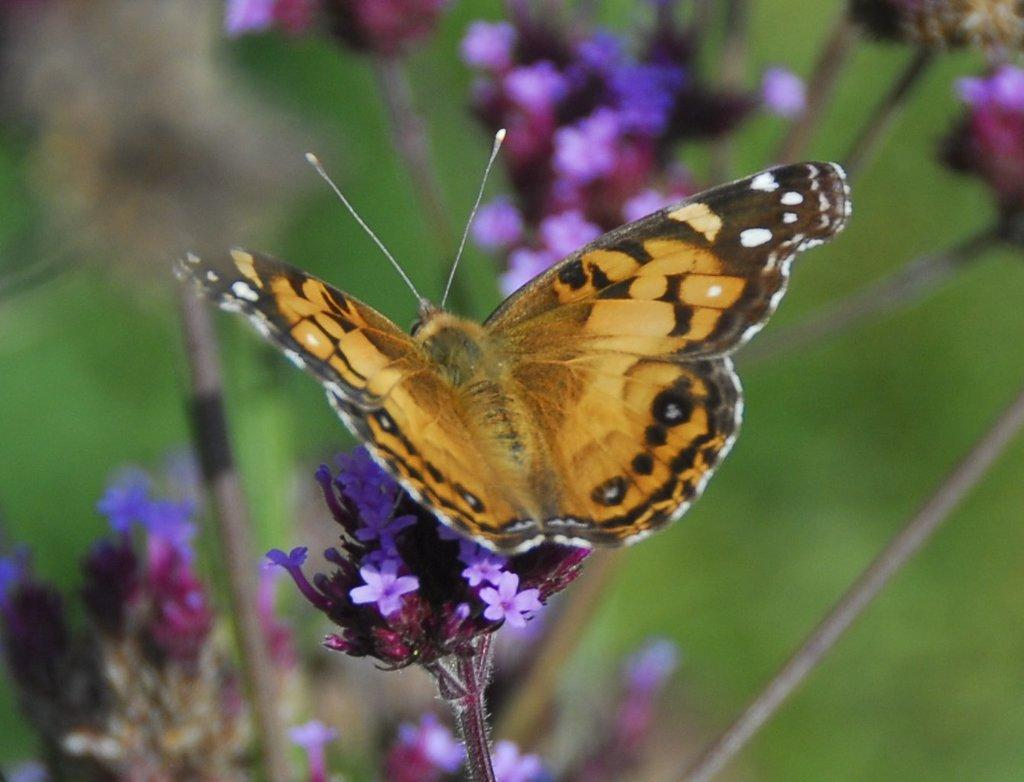What type of creature is present in the image? There is a butterfly in the image. What is the butterfly resting on? The butterfly is on flowering plants. What type of vegetation is visible in the image? There is grass in the image. Where might this image have been taken? The image was likely taken in a garden. When might this image have been taken? The image was likely taken during the day. What type of airport is visible in the image? There is no airport present in the image; it features a butterfly on flowering plants in a garden. Can you see a basket in the image? There is no basket present in the image. 